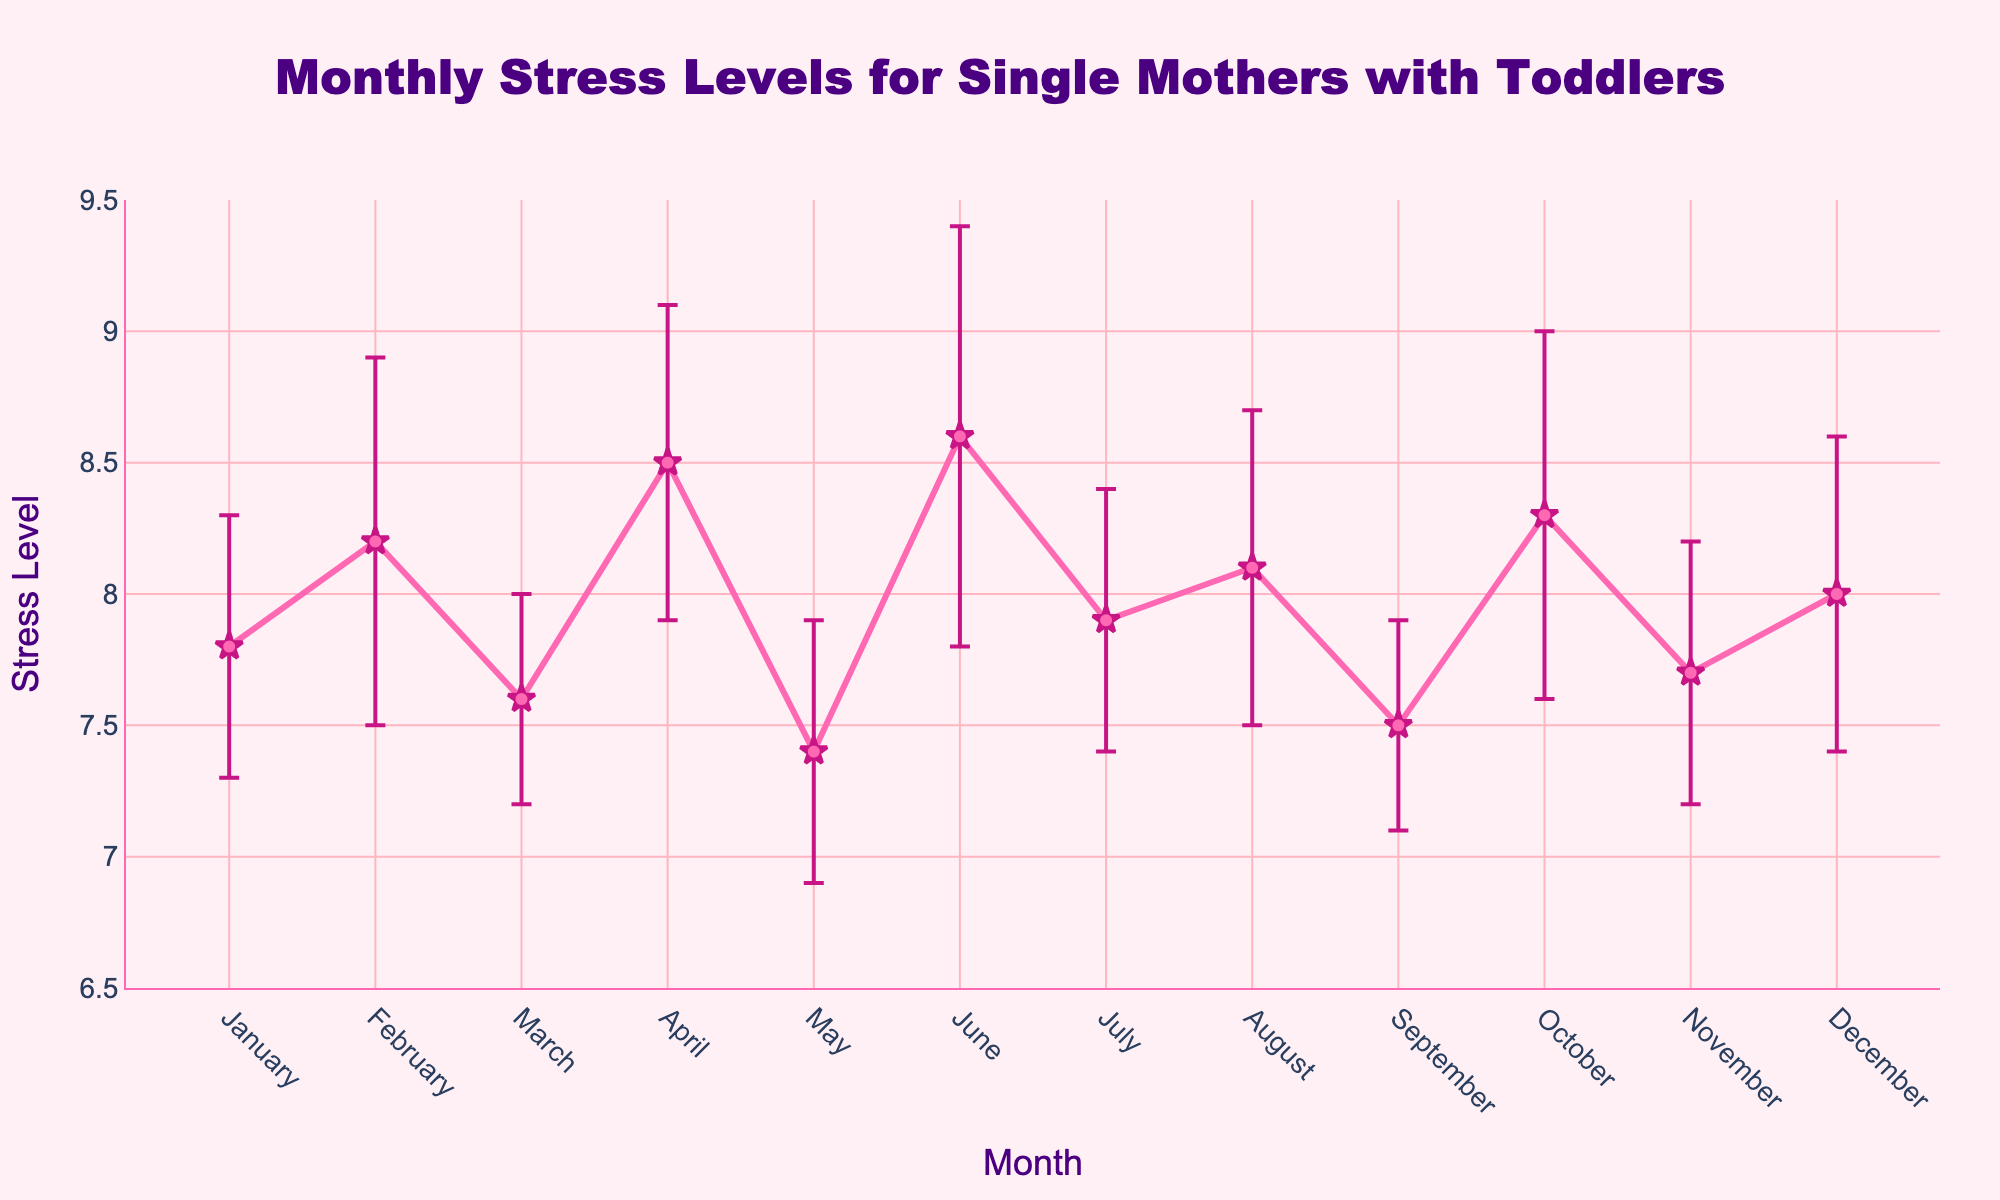Which month has the highest recorded stress level? Referring to the plot, the highest recorded stress level can be seen in June at a level of 8.6.
Answer: June What is the difference in stress level between April and May? April's stress level is recorded at 8.5, while May's stress level is 7.4. The difference is 8.5 - 7.4 = 1.1.
Answer: 1.1 Is the stress level in July higher or lower than in September? Observing the plot, the stress level in July is 7.9, while in September it is 7.5. Hence, the stress level in July is higher than in September.
Answer: Higher What is the average stress level for the first quarter (January to March)? The stress levels for the first quarter are: January (7.8), February (8.2), and March (7.6). The average stress level is calculated as (7.8 + 8.2 + 7.6) / 3 = 7.8667.
Answer: 7.87 Which month shows the highest error bar? The error bars represent the uncertainty and are denoted by the vertical lines around each data point. The month with the highest error bar is June, with an error of 0.8.
Answer: June Which two consecutive months have the largest increase in stress level? By examining each month-to-month change, the largest increase is observed between May and June, where the stress level increases from 7.4 to 8.6.
Answer: May to June Are there any months where the stress level remains the same as the following or preceding month? Observing the plotted stress levels, no two consecutive months have the same stress level; all values are distinct.
Answer: No What is the range of stress levels from the highest to the lowest value? The highest stress level is 8.6 (June) and the lowest is 7.4 (May). The range is 8.6 - 7.4 = 1.2.
Answer: 1.2 Is October’s stress level within the error range of any other month's stress level? October's stress level is 8.3 with an error bar of 0.7, making the range 7.6 to 9.0. August has a stress level of 8.1 with an error bar of 0.6, making its range 7.5 to 8.7, which overlaps with October’s range.
Answer: Yes 